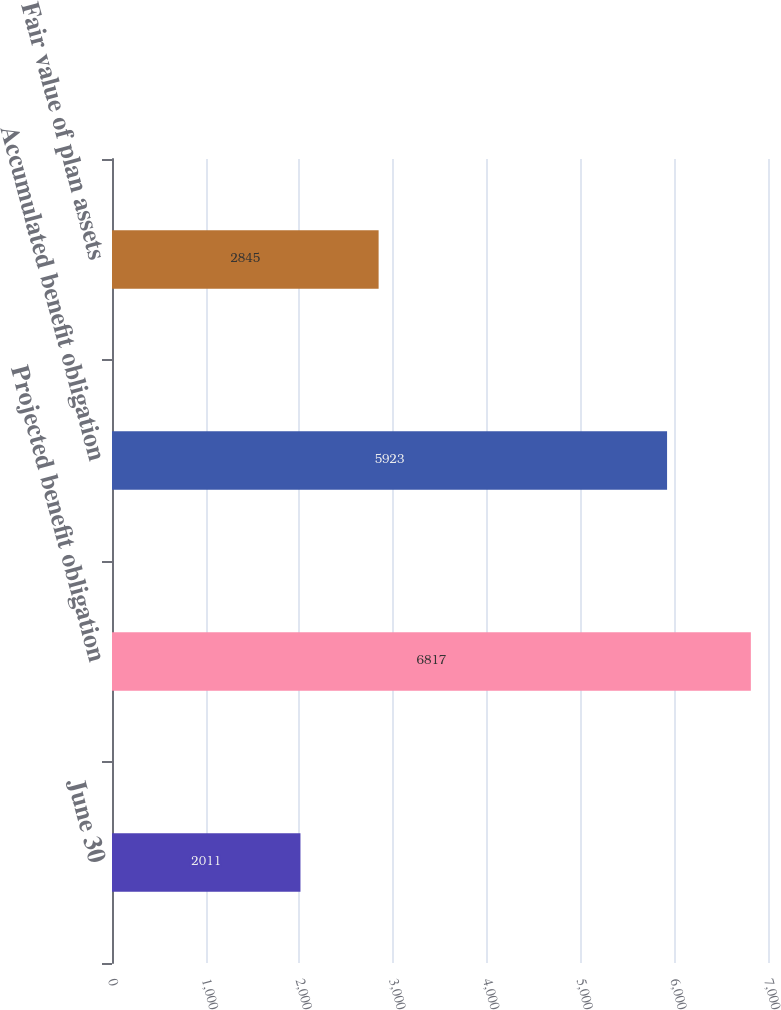Convert chart. <chart><loc_0><loc_0><loc_500><loc_500><bar_chart><fcel>June 30<fcel>Projected benefit obligation<fcel>Accumulated benefit obligation<fcel>Fair value of plan assets<nl><fcel>2011<fcel>6817<fcel>5923<fcel>2845<nl></chart> 